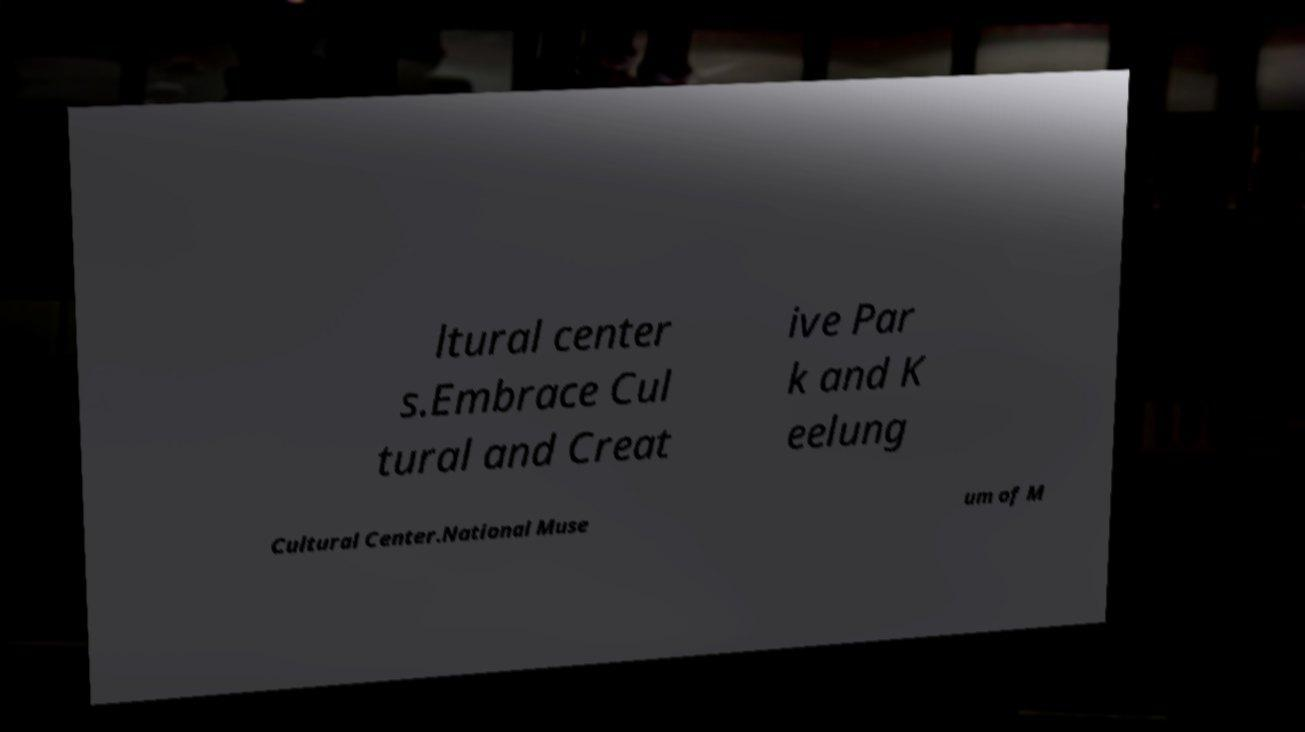For documentation purposes, I need the text within this image transcribed. Could you provide that? ltural center s.Embrace Cul tural and Creat ive Par k and K eelung Cultural Center.National Muse um of M 